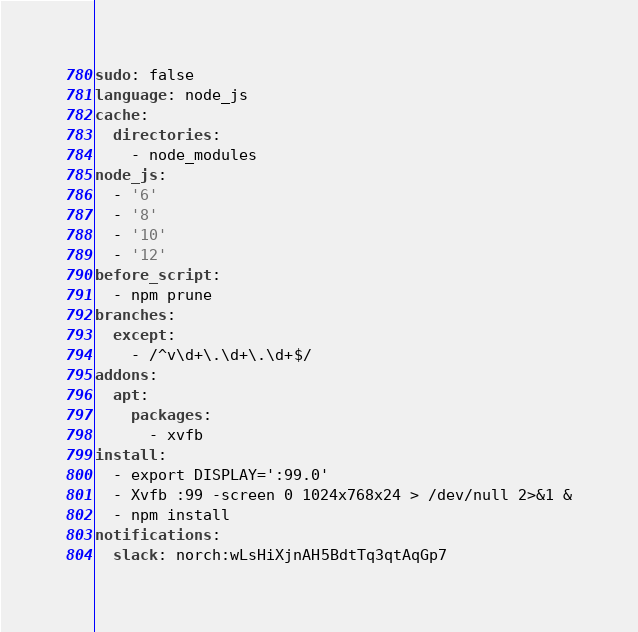<code> <loc_0><loc_0><loc_500><loc_500><_YAML_>sudo: false
language: node_js
cache:
  directories:
    - node_modules
node_js:
  - '6'
  - '8'
  - '10'
  - '12'
before_script:
  - npm prune
branches:
  except:
    - /^v\d+\.\d+\.\d+$/
addons:
  apt:
    packages:
      - xvfb
install:
  - export DISPLAY=':99.0'
  - Xvfb :99 -screen 0 1024x768x24 > /dev/null 2>&1 &
  - npm install
notifications:
  slack: norch:wLsHiXjnAH5BdtTq3qtAqGp7
</code> 